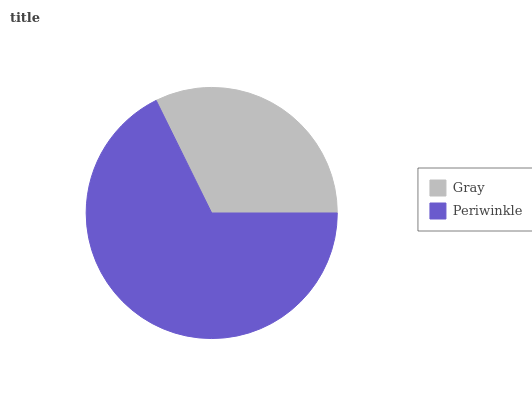Is Gray the minimum?
Answer yes or no. Yes. Is Periwinkle the maximum?
Answer yes or no. Yes. Is Periwinkle the minimum?
Answer yes or no. No. Is Periwinkle greater than Gray?
Answer yes or no. Yes. Is Gray less than Periwinkle?
Answer yes or no. Yes. Is Gray greater than Periwinkle?
Answer yes or no. No. Is Periwinkle less than Gray?
Answer yes or no. No. Is Periwinkle the high median?
Answer yes or no. Yes. Is Gray the low median?
Answer yes or no. Yes. Is Gray the high median?
Answer yes or no. No. Is Periwinkle the low median?
Answer yes or no. No. 